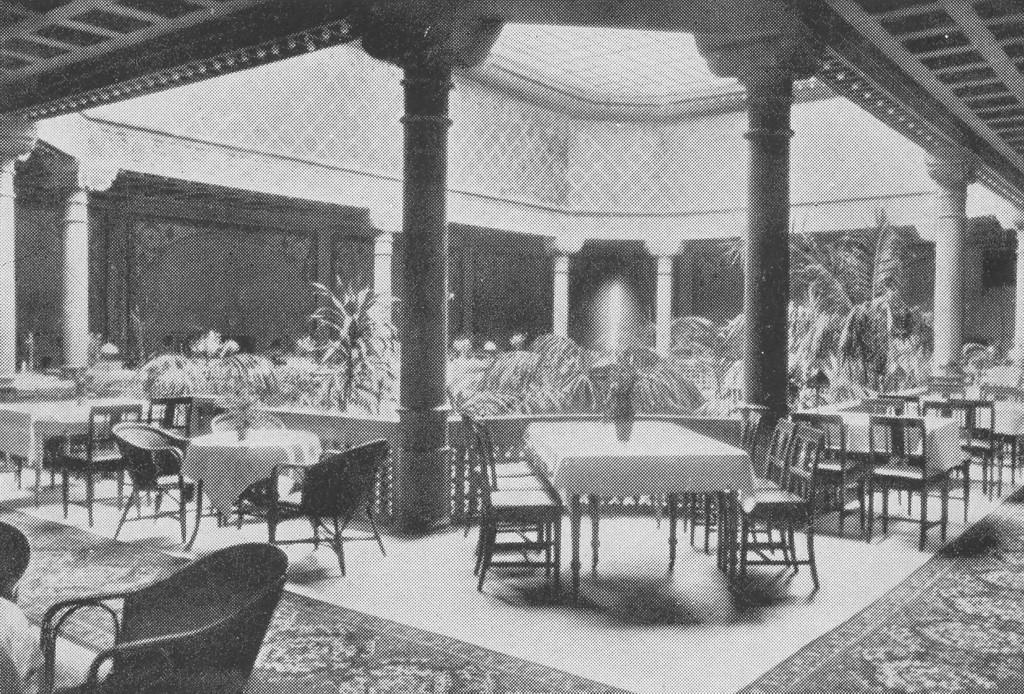What is the primary subject of the image? The primary subject of the image is the many plants. What type of furniture is present in the image? There are tables and chairs in the image. Are there any objects placed on the tables? Yes, there are objects placed on the tables. How much wealth is represented by the cup on the table in the image? There is no cup present in the image, so it is not possible to determine the amount of wealth represented. 